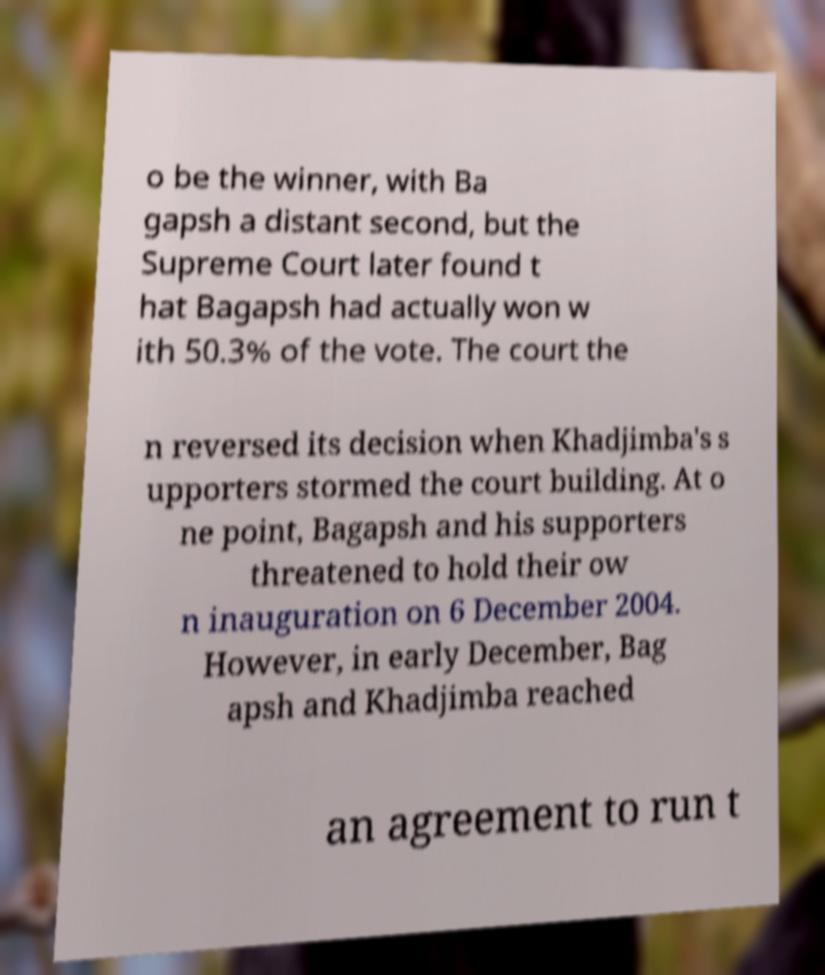What messages or text are displayed in this image? I need them in a readable, typed format. o be the winner, with Ba gapsh a distant second, but the Supreme Court later found t hat Bagapsh had actually won w ith 50.3% of the vote. The court the n reversed its decision when Khadjimba's s upporters stormed the court building. At o ne point, Bagapsh and his supporters threatened to hold their ow n inauguration on 6 December 2004. However, in early December, Bag apsh and Khadjimba reached an agreement to run t 